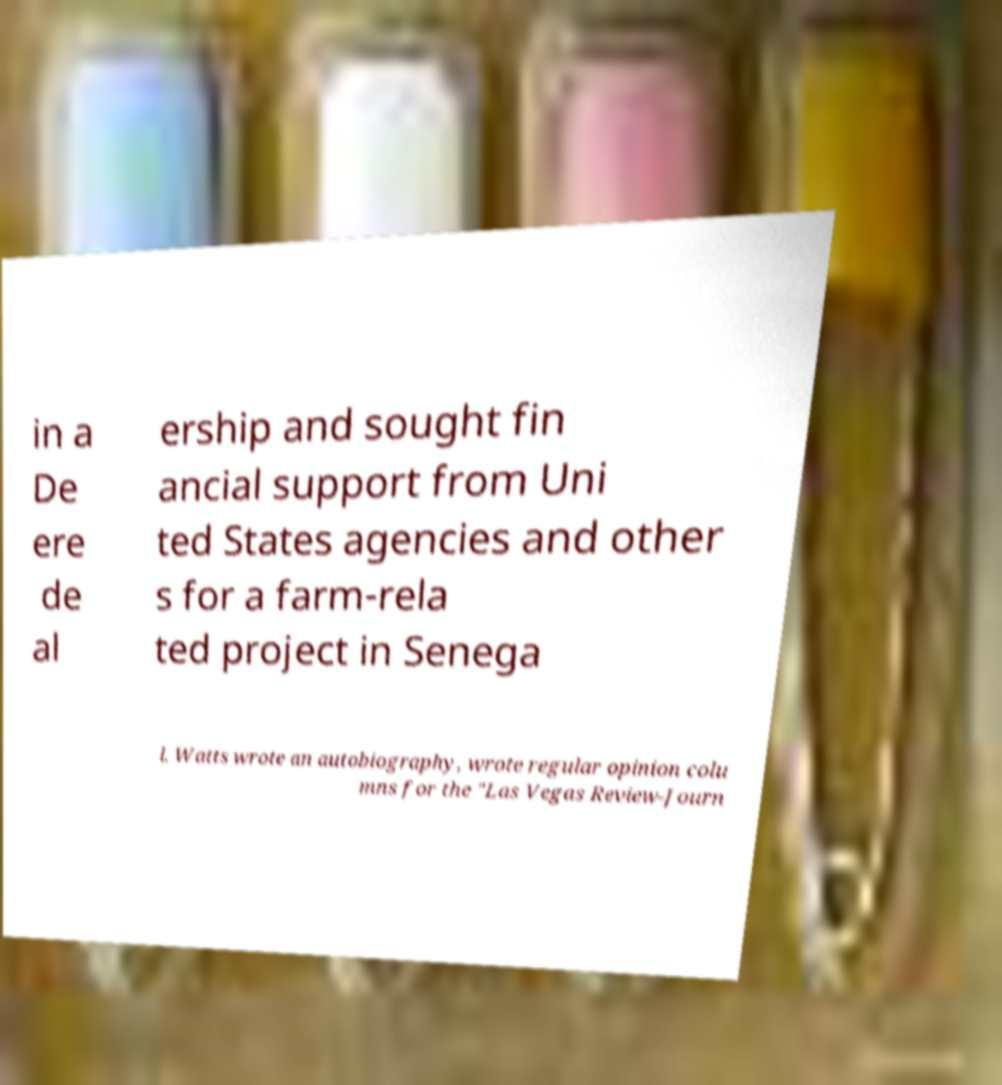I need the written content from this picture converted into text. Can you do that? in a De ere de al ership and sought fin ancial support from Uni ted States agencies and other s for a farm-rela ted project in Senega l. Watts wrote an autobiography, wrote regular opinion colu mns for the "Las Vegas Review-Journ 